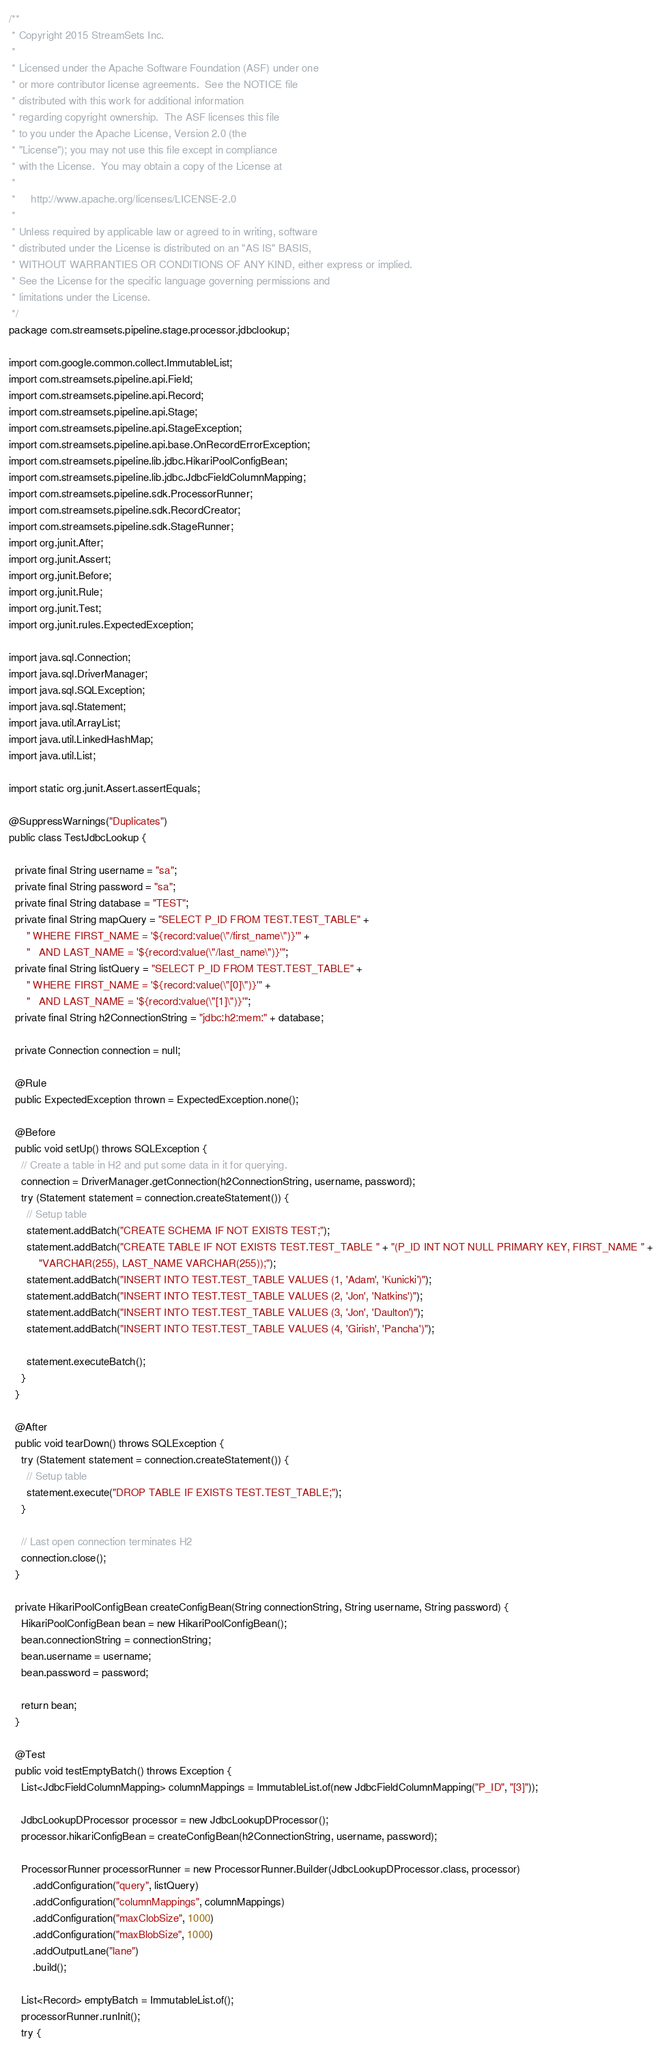<code> <loc_0><loc_0><loc_500><loc_500><_Java_>/**
 * Copyright 2015 StreamSets Inc.
 *
 * Licensed under the Apache Software Foundation (ASF) under one
 * or more contributor license agreements.  See the NOTICE file
 * distributed with this work for additional information
 * regarding copyright ownership.  The ASF licenses this file
 * to you under the Apache License, Version 2.0 (the
 * "License"); you may not use this file except in compliance
 * with the License.  You may obtain a copy of the License at
 *
 *     http://www.apache.org/licenses/LICENSE-2.0
 *
 * Unless required by applicable law or agreed to in writing, software
 * distributed under the License is distributed on an "AS IS" BASIS,
 * WITHOUT WARRANTIES OR CONDITIONS OF ANY KIND, either express or implied.
 * See the License for the specific language governing permissions and
 * limitations under the License.
 */
package com.streamsets.pipeline.stage.processor.jdbclookup;

import com.google.common.collect.ImmutableList;
import com.streamsets.pipeline.api.Field;
import com.streamsets.pipeline.api.Record;
import com.streamsets.pipeline.api.Stage;
import com.streamsets.pipeline.api.StageException;
import com.streamsets.pipeline.api.base.OnRecordErrorException;
import com.streamsets.pipeline.lib.jdbc.HikariPoolConfigBean;
import com.streamsets.pipeline.lib.jdbc.JdbcFieldColumnMapping;
import com.streamsets.pipeline.sdk.ProcessorRunner;
import com.streamsets.pipeline.sdk.RecordCreator;
import com.streamsets.pipeline.sdk.StageRunner;
import org.junit.After;
import org.junit.Assert;
import org.junit.Before;
import org.junit.Rule;
import org.junit.Test;
import org.junit.rules.ExpectedException;

import java.sql.Connection;
import java.sql.DriverManager;
import java.sql.SQLException;
import java.sql.Statement;
import java.util.ArrayList;
import java.util.LinkedHashMap;
import java.util.List;

import static org.junit.Assert.assertEquals;

@SuppressWarnings("Duplicates")
public class TestJdbcLookup {

  private final String username = "sa";
  private final String password = "sa";
  private final String database = "TEST";
  private final String mapQuery = "SELECT P_ID FROM TEST.TEST_TABLE" +
      " WHERE FIRST_NAME = '${record:value(\"/first_name\")}'" +
      "   AND LAST_NAME = '${record:value(\"/last_name\")}'";
  private final String listQuery = "SELECT P_ID FROM TEST.TEST_TABLE" +
      " WHERE FIRST_NAME = '${record:value(\"[0]\")}'" +
      "   AND LAST_NAME = '${record:value(\"[1]\")}'";
  private final String h2ConnectionString = "jdbc:h2:mem:" + database;

  private Connection connection = null;

  @Rule
  public ExpectedException thrown = ExpectedException.none();

  @Before
  public void setUp() throws SQLException {
    // Create a table in H2 and put some data in it for querying.
    connection = DriverManager.getConnection(h2ConnectionString, username, password);
    try (Statement statement = connection.createStatement()) {
      // Setup table
      statement.addBatch("CREATE SCHEMA IF NOT EXISTS TEST;");
      statement.addBatch("CREATE TABLE IF NOT EXISTS TEST.TEST_TABLE " + "(P_ID INT NOT NULL PRIMARY KEY, FIRST_NAME " +
          "VARCHAR(255), LAST_NAME VARCHAR(255));");
      statement.addBatch("INSERT INTO TEST.TEST_TABLE VALUES (1, 'Adam', 'Kunicki')");
      statement.addBatch("INSERT INTO TEST.TEST_TABLE VALUES (2, 'Jon', 'Natkins')");
      statement.addBatch("INSERT INTO TEST.TEST_TABLE VALUES (3, 'Jon', 'Daulton')");
      statement.addBatch("INSERT INTO TEST.TEST_TABLE VALUES (4, 'Girish', 'Pancha')");

      statement.executeBatch();
    }
  }

  @After
  public void tearDown() throws SQLException {
    try (Statement statement = connection.createStatement()) {
      // Setup table
      statement.execute("DROP TABLE IF EXISTS TEST.TEST_TABLE;");
    }

    // Last open connection terminates H2
    connection.close();
  }

  private HikariPoolConfigBean createConfigBean(String connectionString, String username, String password) {
    HikariPoolConfigBean bean = new HikariPoolConfigBean();
    bean.connectionString = connectionString;
    bean.username = username;
    bean.password = password;

    return bean;
  }

  @Test
  public void testEmptyBatch() throws Exception {
    List<JdbcFieldColumnMapping> columnMappings = ImmutableList.of(new JdbcFieldColumnMapping("P_ID", "[3]"));

    JdbcLookupDProcessor processor = new JdbcLookupDProcessor();
    processor.hikariConfigBean = createConfigBean(h2ConnectionString, username, password);

    ProcessorRunner processorRunner = new ProcessorRunner.Builder(JdbcLookupDProcessor.class, processor)
        .addConfiguration("query", listQuery)
        .addConfiguration("columnMappings", columnMappings)
        .addConfiguration("maxClobSize", 1000)
        .addConfiguration("maxBlobSize", 1000)
        .addOutputLane("lane")
        .build();

    List<Record> emptyBatch = ImmutableList.of();
    processorRunner.runInit();
    try {</code> 